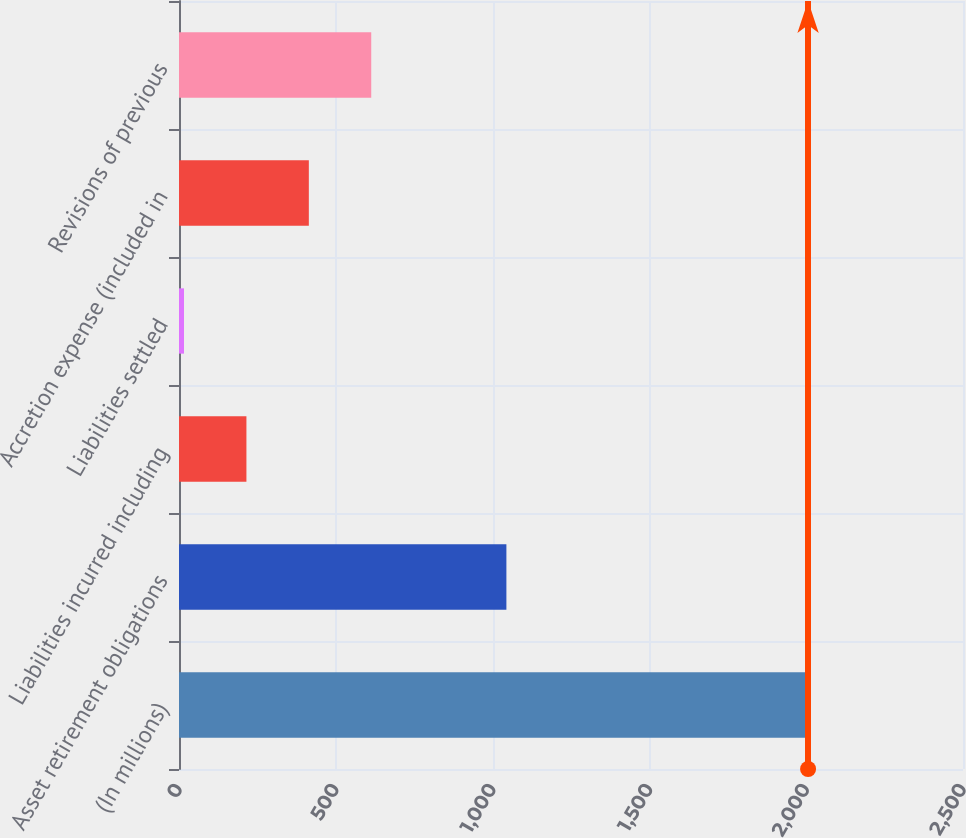<chart> <loc_0><loc_0><loc_500><loc_500><bar_chart><fcel>(In millions)<fcel>Asset retirement obligations<fcel>Liabilities incurred including<fcel>Liabilities settled<fcel>Accretion expense (included in<fcel>Revisions of previous<nl><fcel>2006<fcel>1044<fcel>215<fcel>16<fcel>414<fcel>613<nl></chart> 